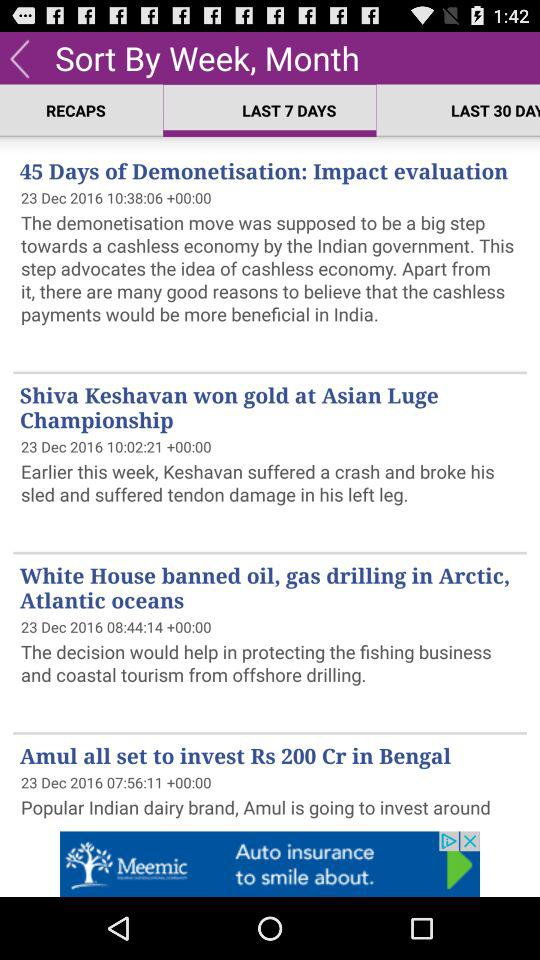On what date was the article "45 Days of Demonetisation: Impact evaluation" posted? The article "45 Days of Demonetisation: Impact evaluation" was posted on December 23, 2016. 